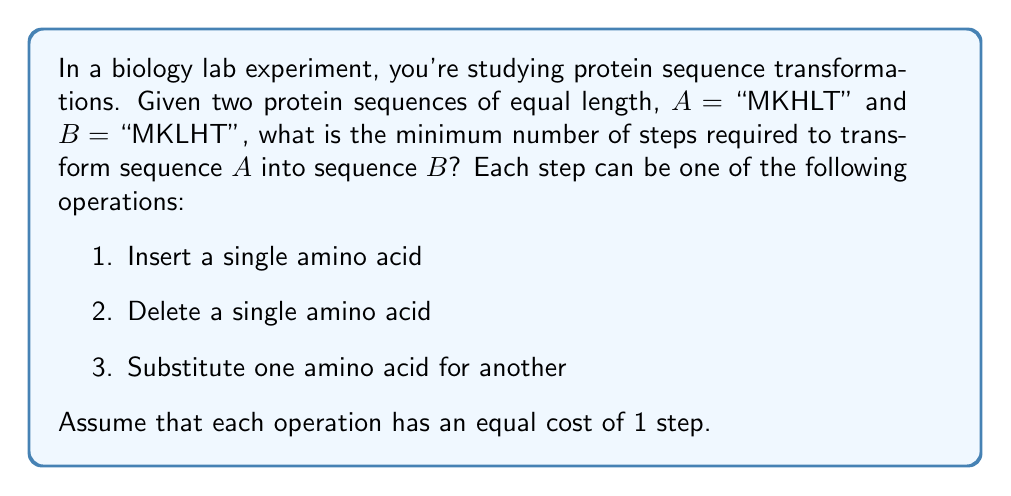Give your solution to this math problem. To solve this problem, we need to use the concept of edit distance, also known as Levenshtein distance in discrete mathematics. This distance measures the minimum number of single-character edits required to change one string into another.

Let's compare the two sequences:

A: MKHLT
B: MKLHT

We can see that the sequences are of equal length (5 amino acids each) and differ in only one position:

1. M - Match
2. K - Match
3. H vs L - Mismatch
4. L - Match
5. T - Match

Since there is only one mismatch, we only need to perform one substitution operation to transform sequence A into sequence B. Specifically, we need to substitute 'H' with 'L' in the third position.

The minimum number of steps is therefore 1.

It's worth noting that in this case, insertion and deletion operations are not necessary, as the sequences are of equal length and we only need to change one amino acid.

In general, for sequences of equal length, the minimum number of steps is equal to the number of positions where the sequences differ (i.e., the Hamming distance). For sequences of different lengths, the problem becomes more complex and may require a dynamic programming approach to solve efficiently.
Answer: 1 step 